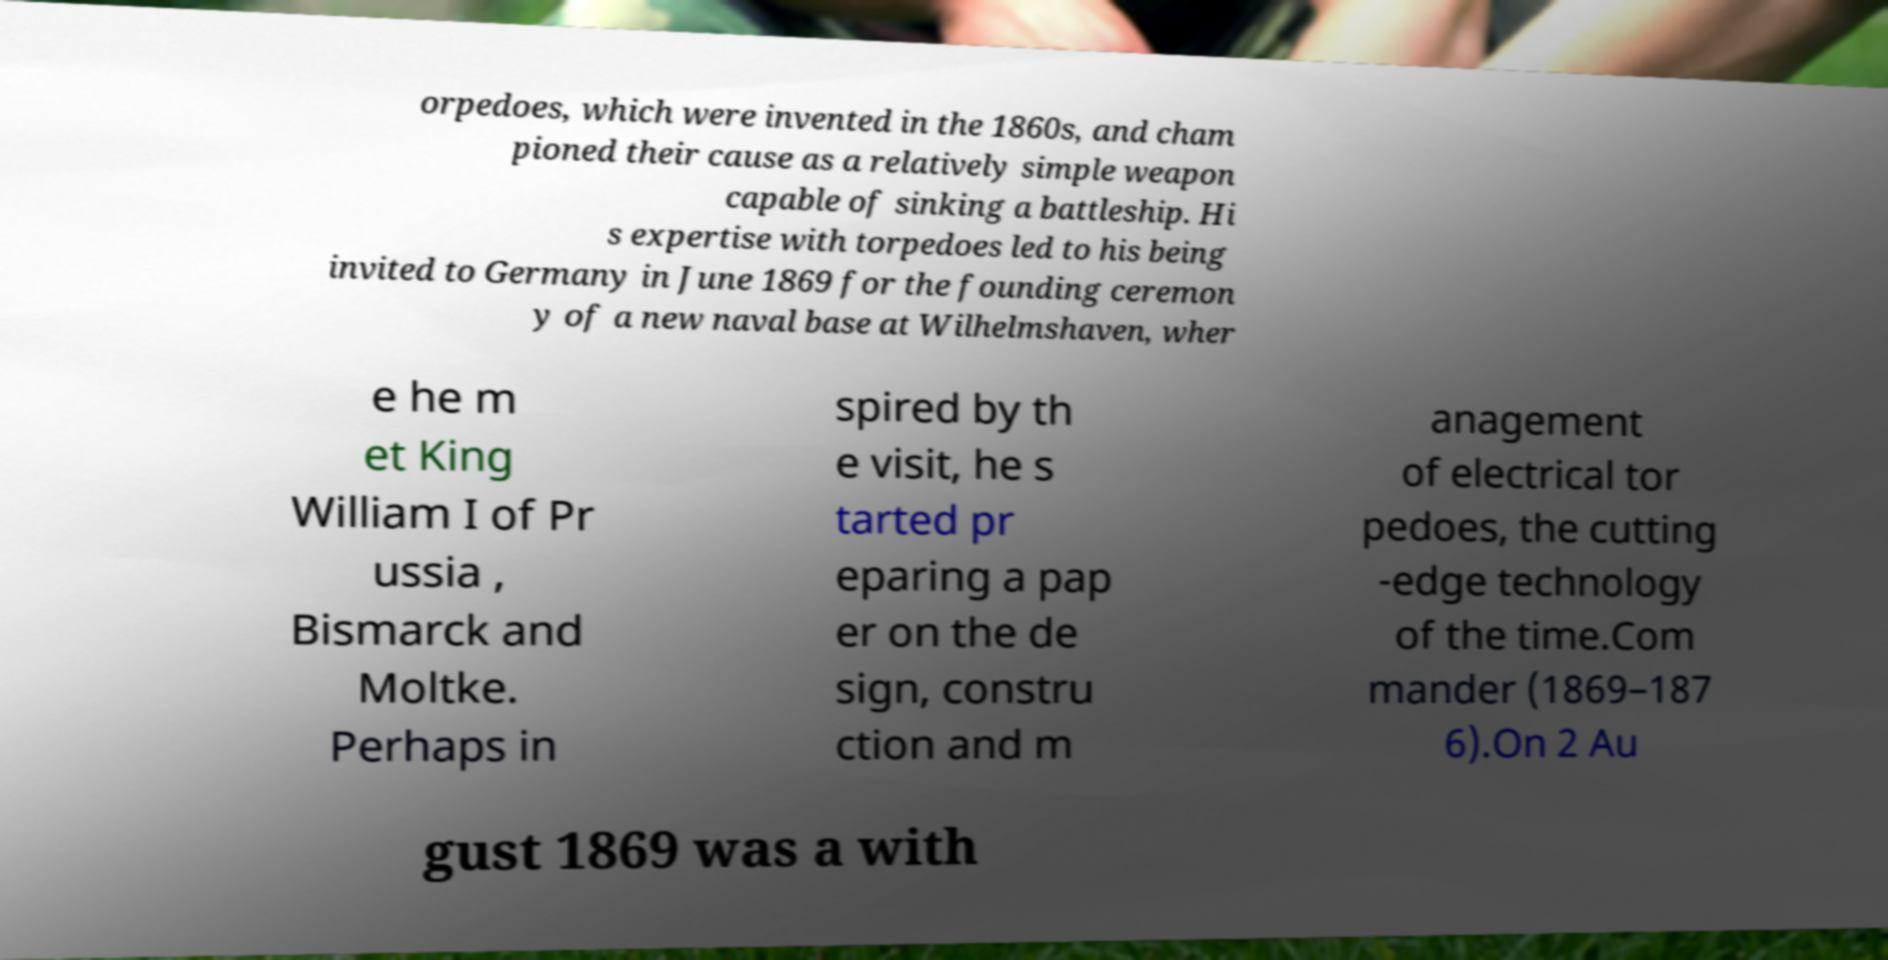What messages or text are displayed in this image? I need them in a readable, typed format. orpedoes, which were invented in the 1860s, and cham pioned their cause as a relatively simple weapon capable of sinking a battleship. Hi s expertise with torpedoes led to his being invited to Germany in June 1869 for the founding ceremon y of a new naval base at Wilhelmshaven, wher e he m et King William I of Pr ussia , Bismarck and Moltke. Perhaps in spired by th e visit, he s tarted pr eparing a pap er on the de sign, constru ction and m anagement of electrical tor pedoes, the cutting -edge technology of the time.Com mander (1869–187 6).On 2 Au gust 1869 was a with 